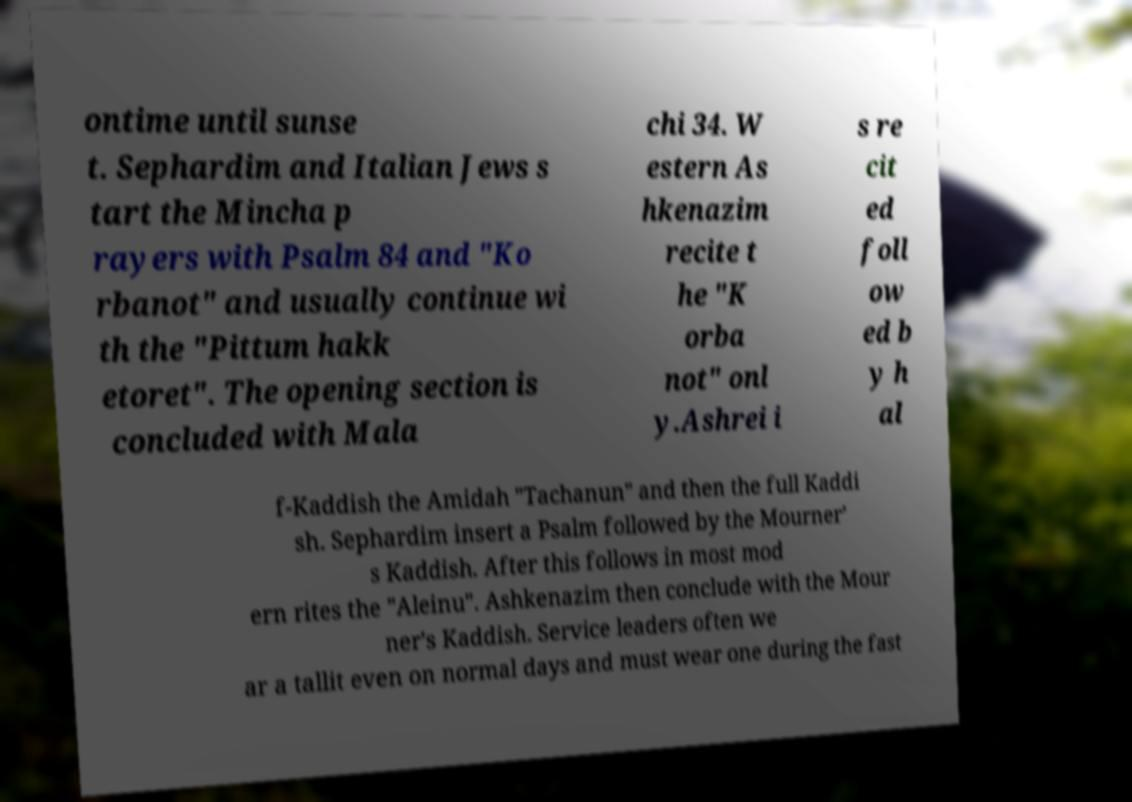Can you accurately transcribe the text from the provided image for me? ontime until sunse t. Sephardim and Italian Jews s tart the Mincha p rayers with Psalm 84 and "Ko rbanot" and usually continue wi th the "Pittum hakk etoret". The opening section is concluded with Mala chi 34. W estern As hkenazim recite t he "K orba not" onl y.Ashrei i s re cit ed foll ow ed b y h al f-Kaddish the Amidah "Tachanun" and then the full Kaddi sh. Sephardim insert a Psalm followed by the Mourner' s Kaddish. After this follows in most mod ern rites the "Aleinu". Ashkenazim then conclude with the Mour ner's Kaddish. Service leaders often we ar a tallit even on normal days and must wear one during the fast 